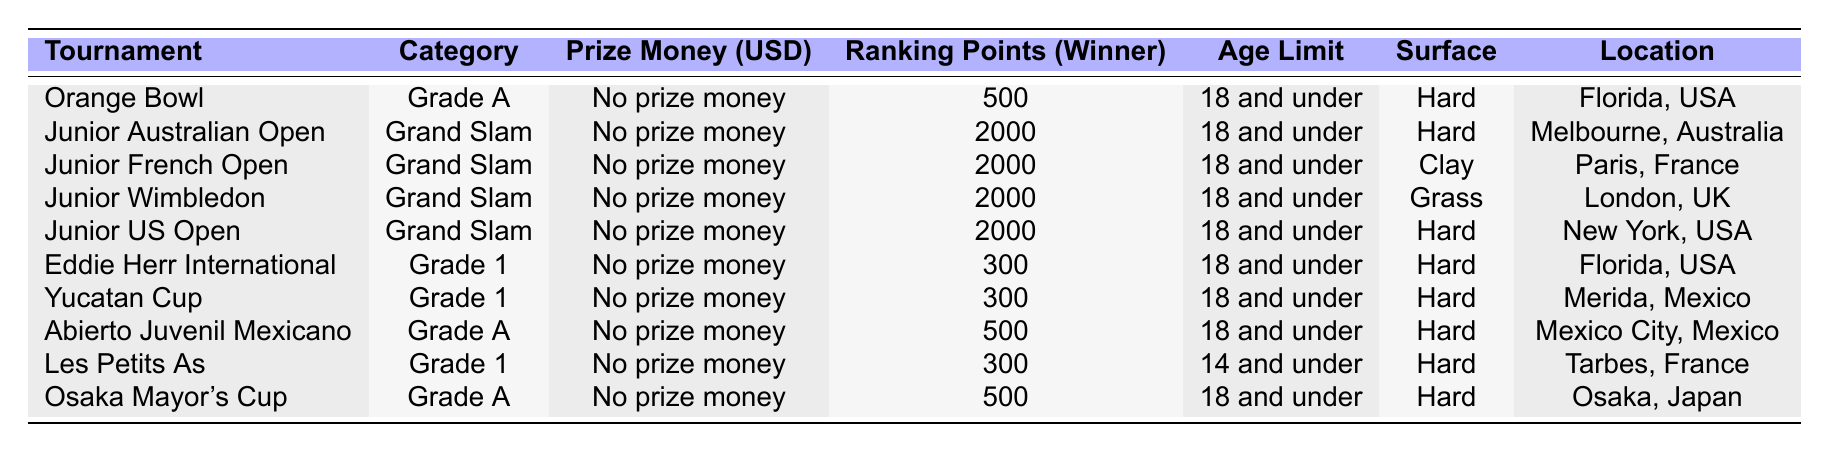What is the prize money for the Junior Australian Open? The table indicates that the Junior Australian Open has no prize money listed.
Answer: No prize money What is the age limit for players in the Les Petits As tournament? Looking at the table, the age limit for Les Petits As is specified as "14 and under."
Answer: 14 and under Which tournament offers the highest ranking points for the winner? By examining the ranking points, the Junior Australian Open, Junior French Open, Junior Wimbledon, and Junior US Open all offer 2000 points each, which is the highest in the table.
Answer: 2000 points How many tournaments have a prize money amount listed as "No prize money"? All tournaments in the table have "No prize money" listed, which includes 10 tournaments.
Answer: 10 tournaments Is the surface of the Abierto Juvenil Mexicano tournament hard? The table indicates that the Abierto Juvenil Mexicano tournament is played on a hard surface.
Answer: Yes Which tournaments are played on grass? The table shows that only the Junior Wimbledon tournament is played on grass.
Answer: Junior Wimbledon What is the total ranking points awarded for winning the Eddie Herr International and Yucatan Cup combined? The Eddie Herr International awards 300 points and the Yucatan Cup awards 300 points. Therefore, the total combined ranking points are 300 + 300 = 600.
Answer: 600 points Which tournament has the same age limit and surface as the Orange Bowl? The Orange Bowl and the Osaka Mayor's Cup both have an age limit of 18 and under and are played on a hard surface.
Answer: Osaka Mayor's Cup How does the ranking points for the tournaments in the Grade A category compare to those in Grade 1? In the table, Grade A tournaments like the Orange Bowl and Abierto Juvenil Mexicano offer 500 points, while all Grade 1 tournaments (Eddie Herr International, Yucatan Cup, and Les Petits As) offer 300 points, showing that Grade A tournaments offer more points.
Answer: Grade A tournaments offer more points Are all tournaments listed in the table held in different locations? Checking the locations, both Eddie Herr International and Junior US Open are held in Florida, USA, thus not all tournaments are held in different locations.
Answer: No Which two tournaments have the lowest ranking points for the winner? The Eddie Herr International, Yucatan Cup, and Les Petits As all have the lowest ranking points, at 300 for Eddie Herr International and Yucatan Cup.
Answer: 300 points 